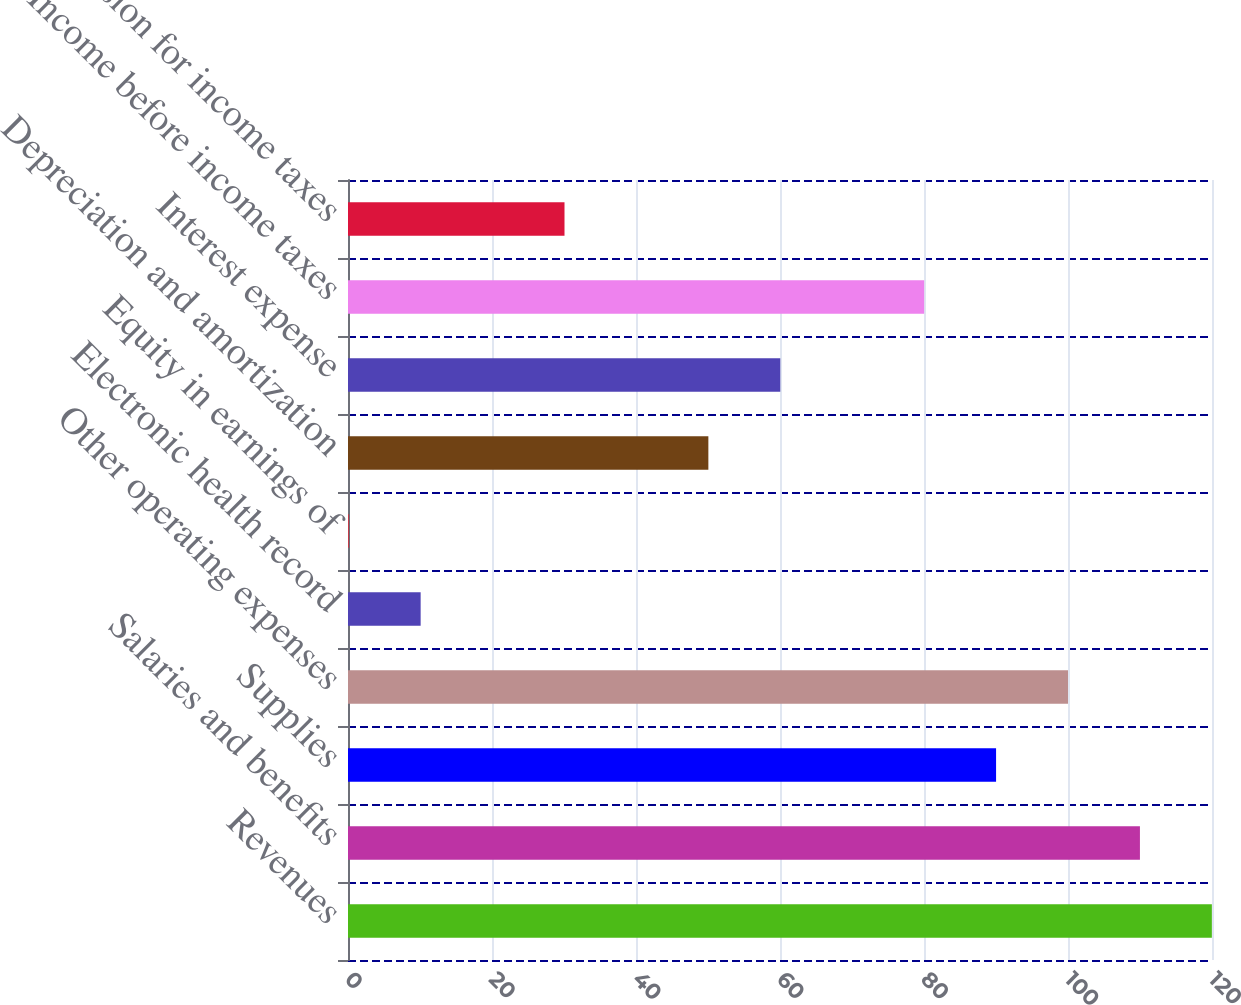<chart> <loc_0><loc_0><loc_500><loc_500><bar_chart><fcel>Revenues<fcel>Salaries and benefits<fcel>Supplies<fcel>Other operating expenses<fcel>Electronic health record<fcel>Equity in earnings of<fcel>Depreciation and amortization<fcel>Interest expense<fcel>Income before income taxes<fcel>Provision for income taxes<nl><fcel>119.98<fcel>109.99<fcel>90.01<fcel>100<fcel>10.09<fcel>0.1<fcel>50.05<fcel>60.04<fcel>80.02<fcel>30.07<nl></chart> 